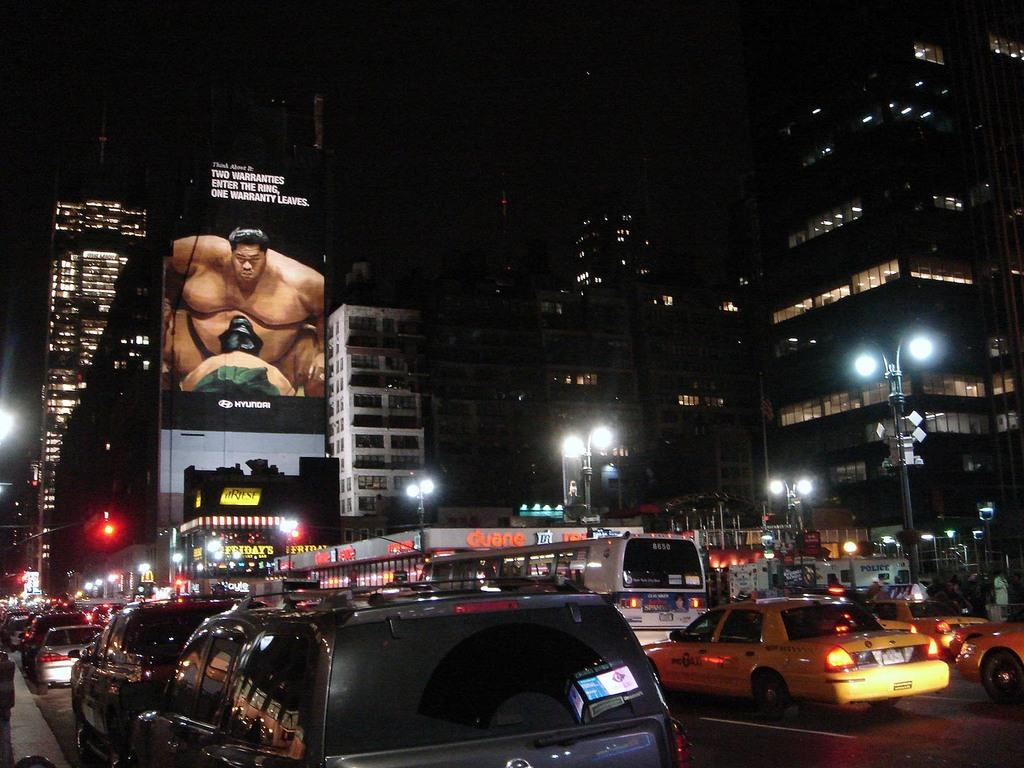What type of structures can be seen in the image? There are buildings in the image. What else can be seen in the image besides the buildings? There are lights, poles, vehicles on the road, and a board visible in the image. What might the lights be used for in the image? The lights could be used for illumination or signaling purposes in the image. What are the vehicles on the road at the bottom of the image? The vehicles on the road at the bottom of the image are likely cars, buses, or other types of transportation. What type of sponge is being used to write on the board in the image? There is no sponge present in the image, and no writing is being done on the board. What type of prose can be seen on the board in the image? There is no prose visible on the board in the image. 